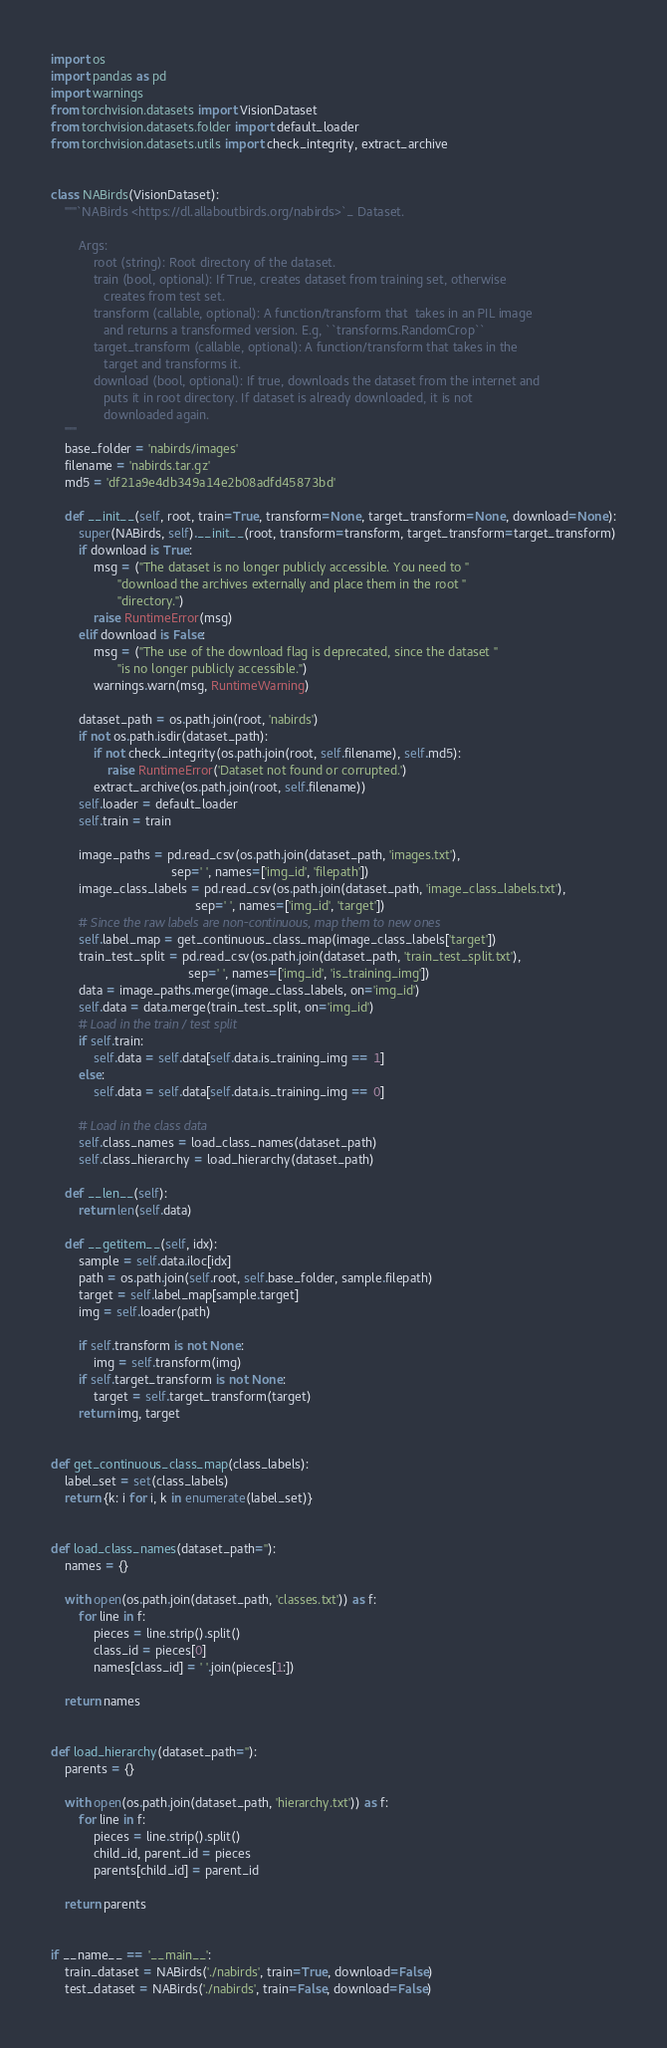<code> <loc_0><loc_0><loc_500><loc_500><_Python_>import os
import pandas as pd
import warnings
from torchvision.datasets import VisionDataset
from torchvision.datasets.folder import default_loader
from torchvision.datasets.utils import check_integrity, extract_archive


class NABirds(VisionDataset):
    """`NABirds <https://dl.allaboutbirds.org/nabirds>`_ Dataset.

        Args:
            root (string): Root directory of the dataset.
            train (bool, optional): If True, creates dataset from training set, otherwise
               creates from test set.
            transform (callable, optional): A function/transform that  takes in an PIL image
               and returns a transformed version. E.g, ``transforms.RandomCrop``
            target_transform (callable, optional): A function/transform that takes in the
               target and transforms it.
            download (bool, optional): If true, downloads the dataset from the internet and
               puts it in root directory. If dataset is already downloaded, it is not
               downloaded again.
    """
    base_folder = 'nabirds/images'
    filename = 'nabirds.tar.gz'
    md5 = 'df21a9e4db349a14e2b08adfd45873bd'

    def __init__(self, root, train=True, transform=None, target_transform=None, download=None):
        super(NABirds, self).__init__(root, transform=transform, target_transform=target_transform)
        if download is True:
            msg = ("The dataset is no longer publicly accessible. You need to "
                   "download the archives externally and place them in the root "
                   "directory.")
            raise RuntimeError(msg)
        elif download is False:
            msg = ("The use of the download flag is deprecated, since the dataset "
                   "is no longer publicly accessible.")
            warnings.warn(msg, RuntimeWarning)

        dataset_path = os.path.join(root, 'nabirds')
        if not os.path.isdir(dataset_path):
            if not check_integrity(os.path.join(root, self.filename), self.md5):
                raise RuntimeError('Dataset not found or corrupted.')
            extract_archive(os.path.join(root, self.filename))
        self.loader = default_loader
        self.train = train

        image_paths = pd.read_csv(os.path.join(dataset_path, 'images.txt'),
                                  sep=' ', names=['img_id', 'filepath'])
        image_class_labels = pd.read_csv(os.path.join(dataset_path, 'image_class_labels.txt'),
                                         sep=' ', names=['img_id', 'target'])
        # Since the raw labels are non-continuous, map them to new ones
        self.label_map = get_continuous_class_map(image_class_labels['target'])
        train_test_split = pd.read_csv(os.path.join(dataset_path, 'train_test_split.txt'),
                                       sep=' ', names=['img_id', 'is_training_img'])
        data = image_paths.merge(image_class_labels, on='img_id')
        self.data = data.merge(train_test_split, on='img_id')
        # Load in the train / test split
        if self.train:
            self.data = self.data[self.data.is_training_img == 1]
        else:
            self.data = self.data[self.data.is_training_img == 0]

        # Load in the class data
        self.class_names = load_class_names(dataset_path)
        self.class_hierarchy = load_hierarchy(dataset_path)

    def __len__(self):
        return len(self.data)

    def __getitem__(self, idx):
        sample = self.data.iloc[idx]
        path = os.path.join(self.root, self.base_folder, sample.filepath)
        target = self.label_map[sample.target]
        img = self.loader(path)

        if self.transform is not None:
            img = self.transform(img)
        if self.target_transform is not None:
            target = self.target_transform(target)
        return img, target


def get_continuous_class_map(class_labels):
    label_set = set(class_labels)
    return {k: i for i, k in enumerate(label_set)}


def load_class_names(dataset_path=''):
    names = {}

    with open(os.path.join(dataset_path, 'classes.txt')) as f:
        for line in f:
            pieces = line.strip().split()
            class_id = pieces[0]
            names[class_id] = ' '.join(pieces[1:])

    return names


def load_hierarchy(dataset_path=''):
    parents = {}

    with open(os.path.join(dataset_path, 'hierarchy.txt')) as f:
        for line in f:
            pieces = line.strip().split()
            child_id, parent_id = pieces
            parents[child_id] = parent_id

    return parents


if __name__ == '__main__':
    train_dataset = NABirds('./nabirds', train=True, download=False)
    test_dataset = NABirds('./nabirds', train=False, download=False)
</code> 